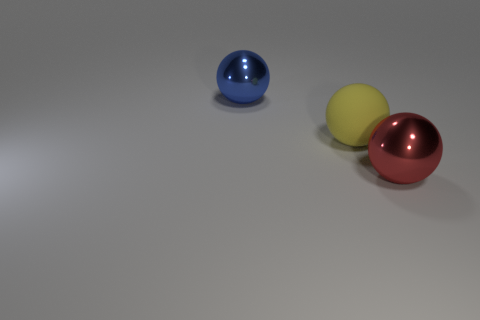Add 2 red balls. How many objects exist? 5 Add 3 red shiny spheres. How many red shiny spheres are left? 4 Add 2 large cyan matte objects. How many large cyan matte objects exist? 2 Subtract 0 yellow cubes. How many objects are left? 3 Subtract all big purple rubber cylinders. Subtract all rubber spheres. How many objects are left? 2 